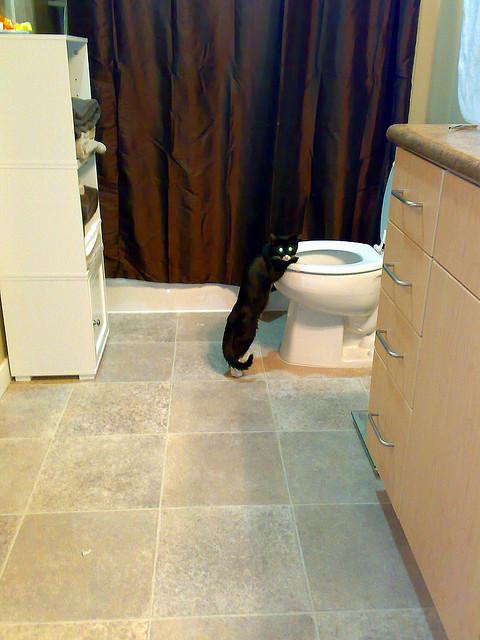Does the vanity have drawers?
Write a very short answer. Yes. Is this cat hoping his owner drops some food on the floor?
Quick response, please. No. What animal is in this room?
Answer briefly. Cat. Are the curtains brown?
Quick response, please. Yes. 